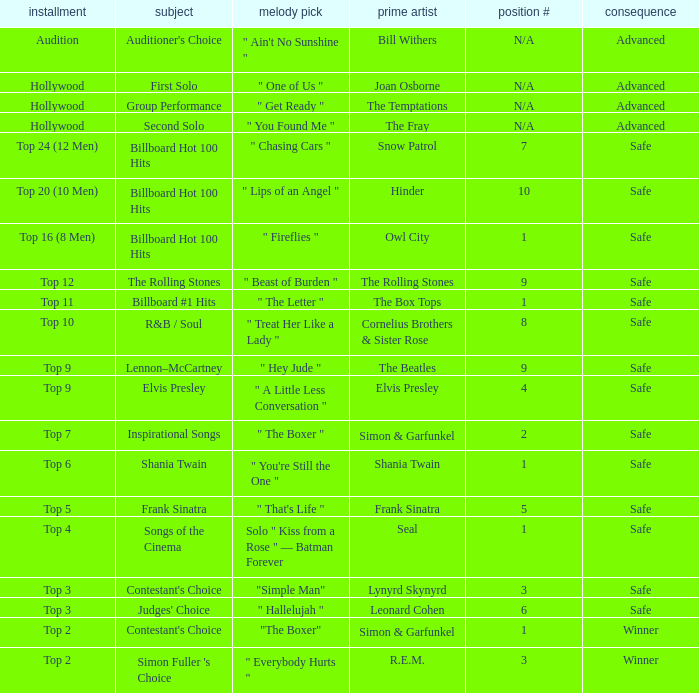The original artist Joan Osborne has what result? Advanced. 